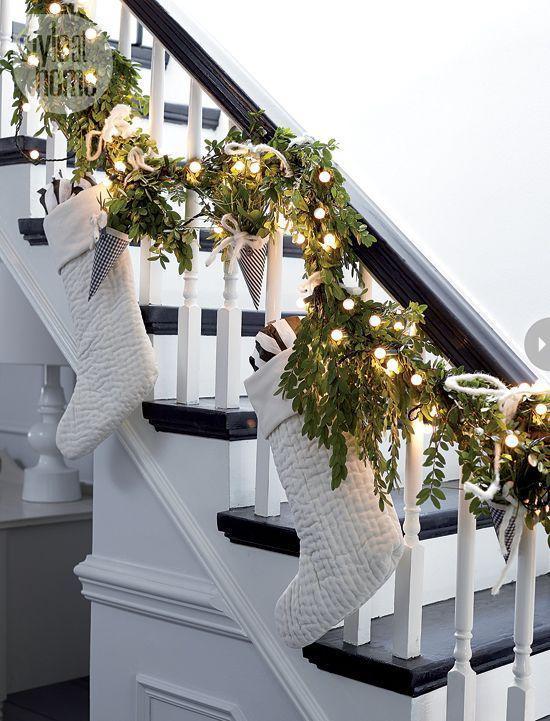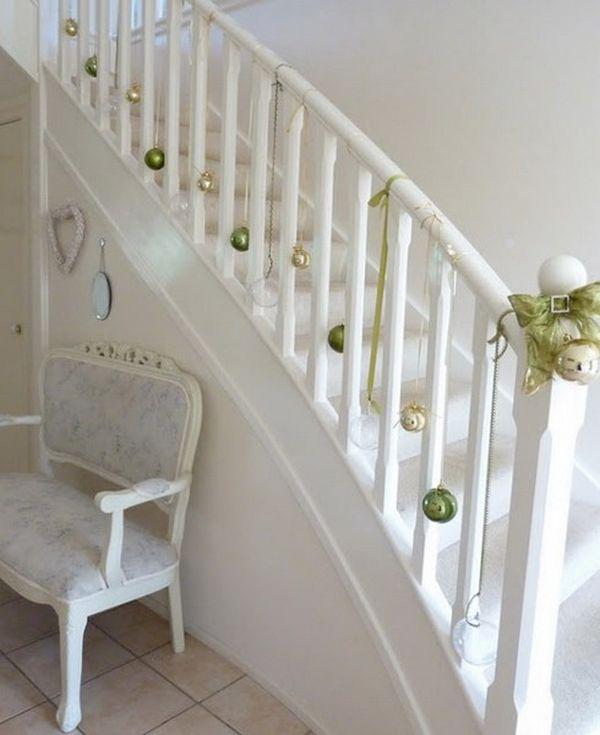The first image is the image on the left, the second image is the image on the right. For the images shown, is this caption "Stockings are hanging from the left staircase." true? Answer yes or no. Yes. The first image is the image on the left, the second image is the image on the right. Considering the images on both sides, is "There is a railing decorated with holiday lights." valid? Answer yes or no. Yes. 